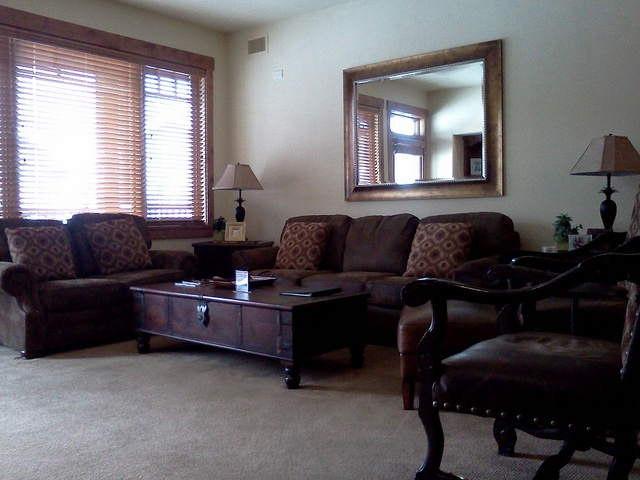Describe the objects in this image and their specific colors. I can see chair in gray and black tones, couch in gray, black, navy, and purple tones, couch in gray, black, and maroon tones, chair in gray and black tones, and potted plant in gray, black, darkgreen, and purple tones in this image. 